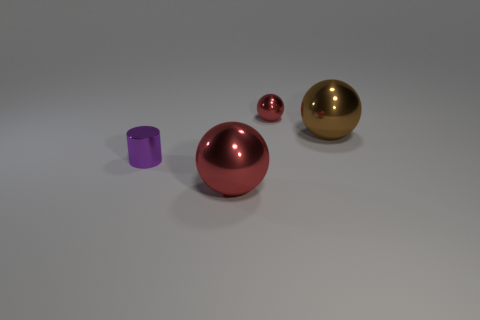There is a large red ball; are there any red spheres behind it?
Keep it short and to the point. Yes. The large metal sphere right of the tiny metal sphere is what color?
Provide a succinct answer. Brown. What is the thing that is behind the brown sphere that is to the right of the purple thing made of?
Provide a succinct answer. Metal. Are there fewer cylinders that are behind the small purple object than big things right of the large brown metallic thing?
Your response must be concise. No. What number of red objects are either small cylinders or small spheres?
Provide a short and direct response. 1. Is the number of big brown spheres that are left of the big red sphere the same as the number of purple cylinders?
Ensure brevity in your answer.  No. What number of objects are either metallic spheres or big spheres behind the tiny purple metallic cylinder?
Offer a very short reply. 3. Is the shiny cylinder the same color as the tiny sphere?
Ensure brevity in your answer.  No. Is there a yellow cube made of the same material as the tiny purple cylinder?
Your response must be concise. No. There is another small thing that is the same shape as the brown metal object; what is its color?
Keep it short and to the point. Red. 